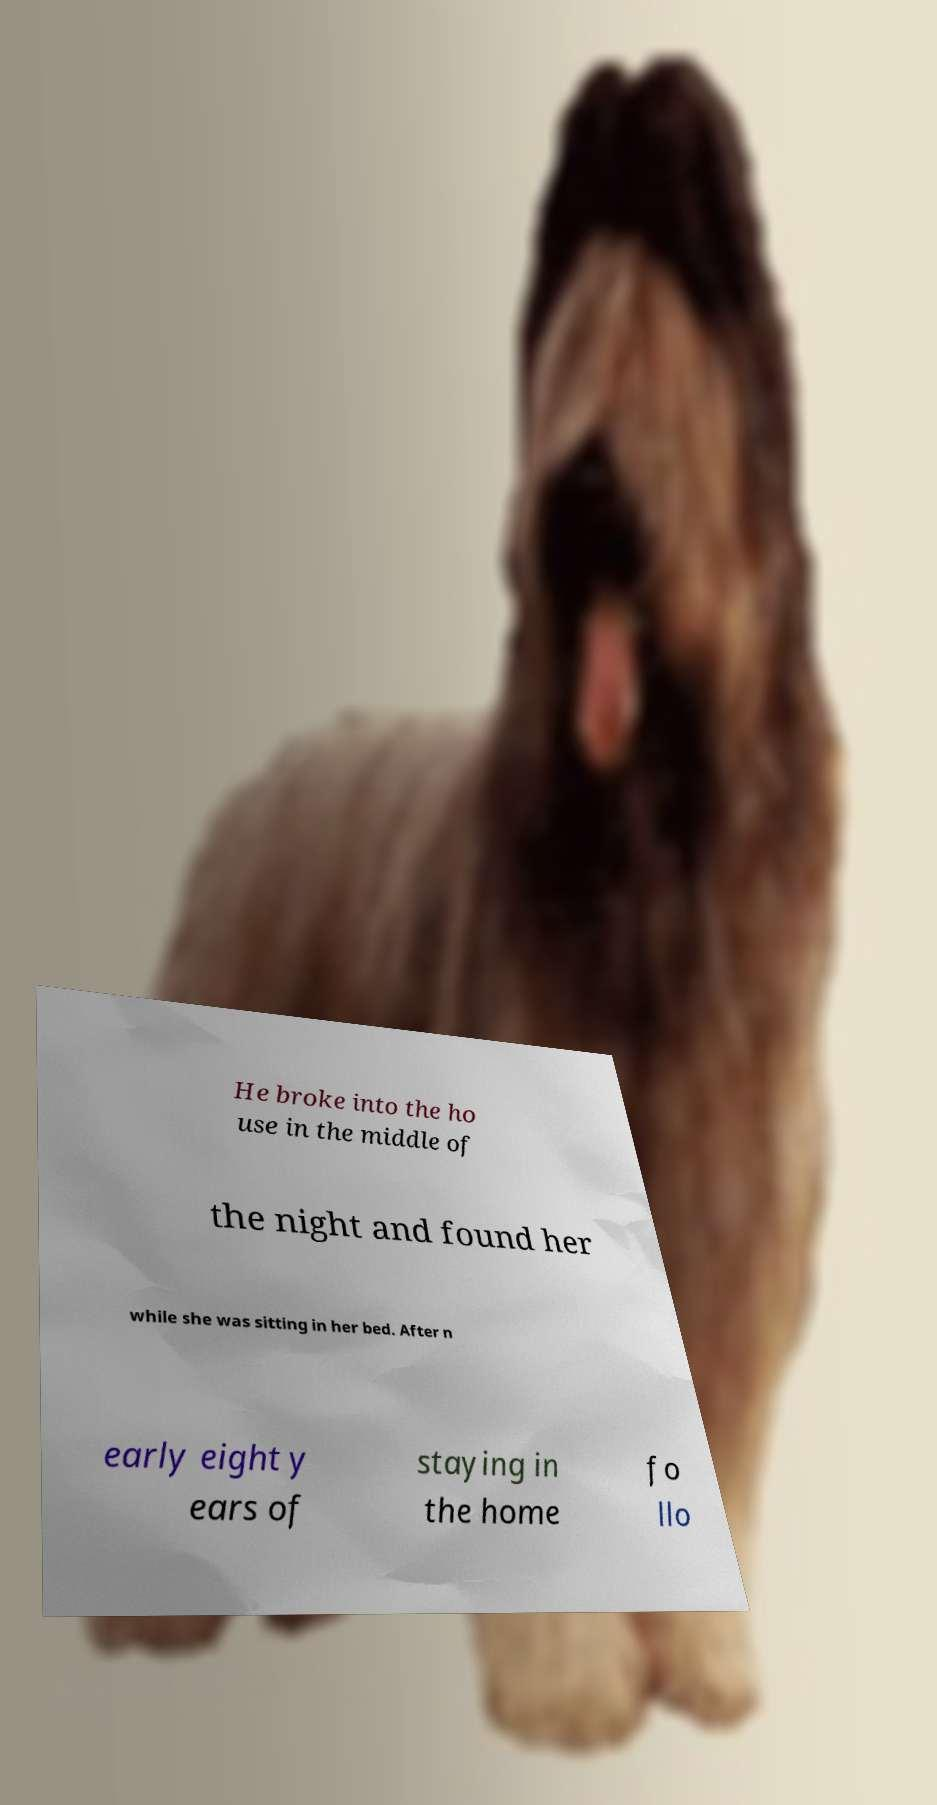What messages or text are displayed in this image? I need them in a readable, typed format. He broke into the ho use in the middle of the night and found her while she was sitting in her bed. After n early eight y ears of staying in the home fo llo 